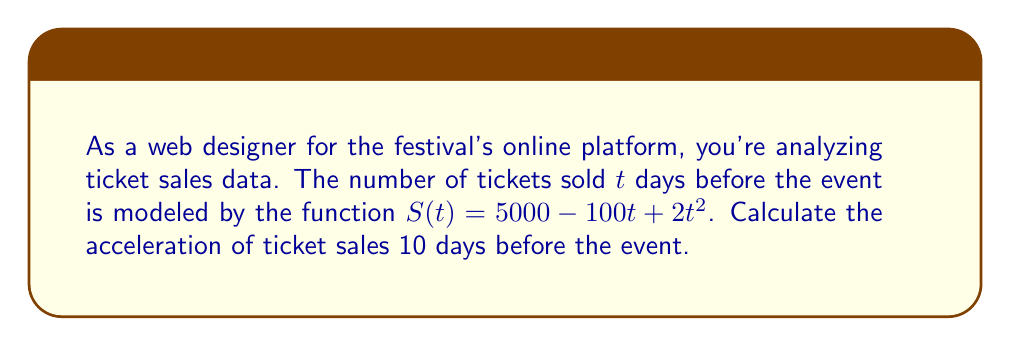Solve this math problem. To find the acceleration of ticket sales, we need to calculate the second derivative of the sales function $S(t)$.

Step 1: Find the first derivative (velocity of sales)
$$\frac{dS}{dt} = S'(t) = -100 + 4t$$

Step 2: Find the second derivative (acceleration of sales)
$$\frac{d^2S}{dt^2} = S''(t) = 4$$

Step 3: The acceleration is constant and equal to 4 tickets per day^2.

Step 4: Since the acceleration is constant, it doesn't matter how many days before the event we calculate it. The acceleration 10 days before the event is still 4 tickets per day^2.
Answer: $4$ tickets/day$^2$ 